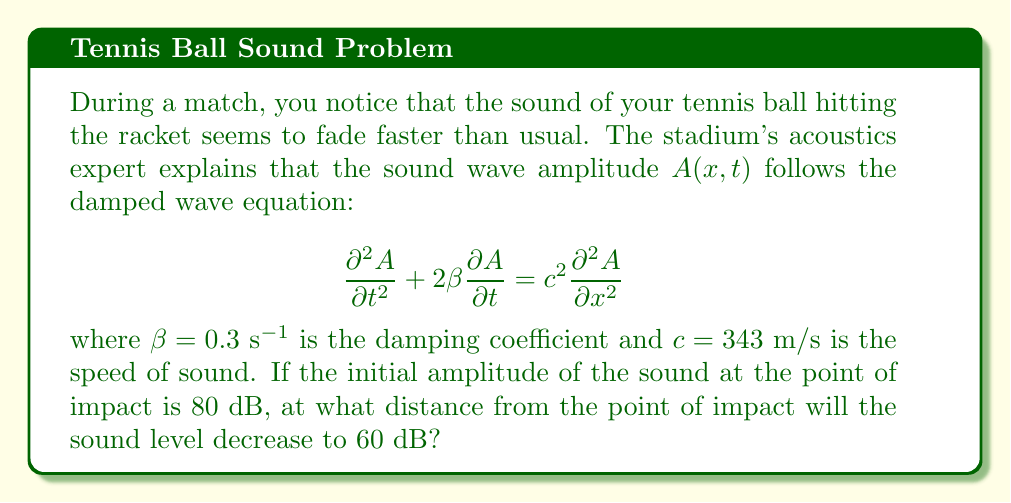Show me your answer to this math problem. To solve this problem, we need to follow these steps:

1) The general solution to the damped wave equation is of the form:
   
   $$A(x,t) = A_0 e^{-\beta t} e^{i(kx - \omega t)}$$

   where $A_0$ is the initial amplitude, $k$ is the wave number, and $\omega$ is the angular frequency.

2) We're interested in the spatial decay, so we can focus on the amplitude at a fixed time:
   
   $$A(x) = A_0 e^{-\alpha x}$$

   where $\alpha$ is the spatial decay constant.

3) The relationship between $\alpha$, $\beta$, and $c$ is:
   
   $$\alpha = \frac{\beta}{c}$$

4) Substituting the given values:
   
   $$\alpha = \frac{0.3 \text{ s}^{-1}}{343 \text{ m/s}} = 8.75 \times 10^{-4} \text{ m}^{-1}$$

5) The sound level in decibels is related to amplitude by:
   
   $$L = 20 \log_{10}\left(\frac{A}{A_{\text{ref}}}\right)$$

6) The change in sound level from 80 dB to 60 dB corresponds to:
   
   $$\frac{A}{A_0} = 10^{\frac{60-80}{20}} = 0.1$$

7) Using the spatial decay equation:
   
   $$0.1 = e^{-\alpha x}$$

8) Taking the natural log of both sides:
   
   $$\ln(0.1) = -\alpha x$$

9) Solving for $x$:
   
   $$x = -\frac{\ln(0.1)}{\alpha} = -\frac{\ln(0.1)}{8.75 \times 10^{-4}} \approx 2632 \text{ m}$$
Answer: 2632 m 